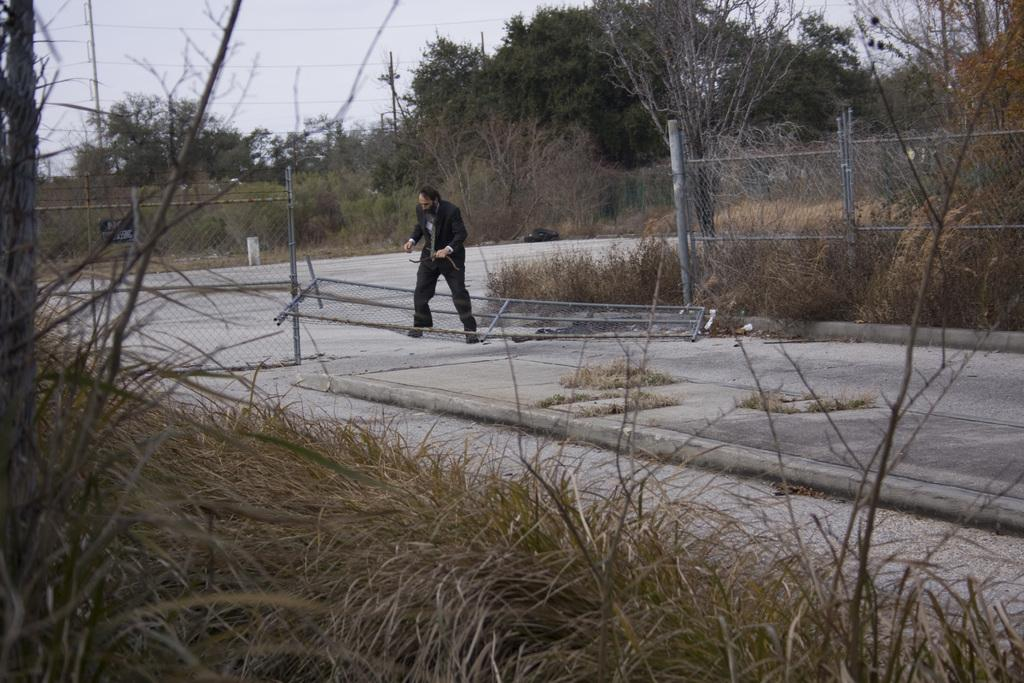What is the main subject of the image? There is a man standing in the image. Can you describe what the man is wearing? The man is wearing clothes and shoes. What can be seen in the background of the image? There is a fence, grass, a road, trees, an electric pole, electric wires, and the sky visible in the image. Is there a maid cleaning the property in the image? There is no maid or property visible in the image; it features a man standing and various background elements. How many hydrants are present in the image? There are no hydrants present in the image. 